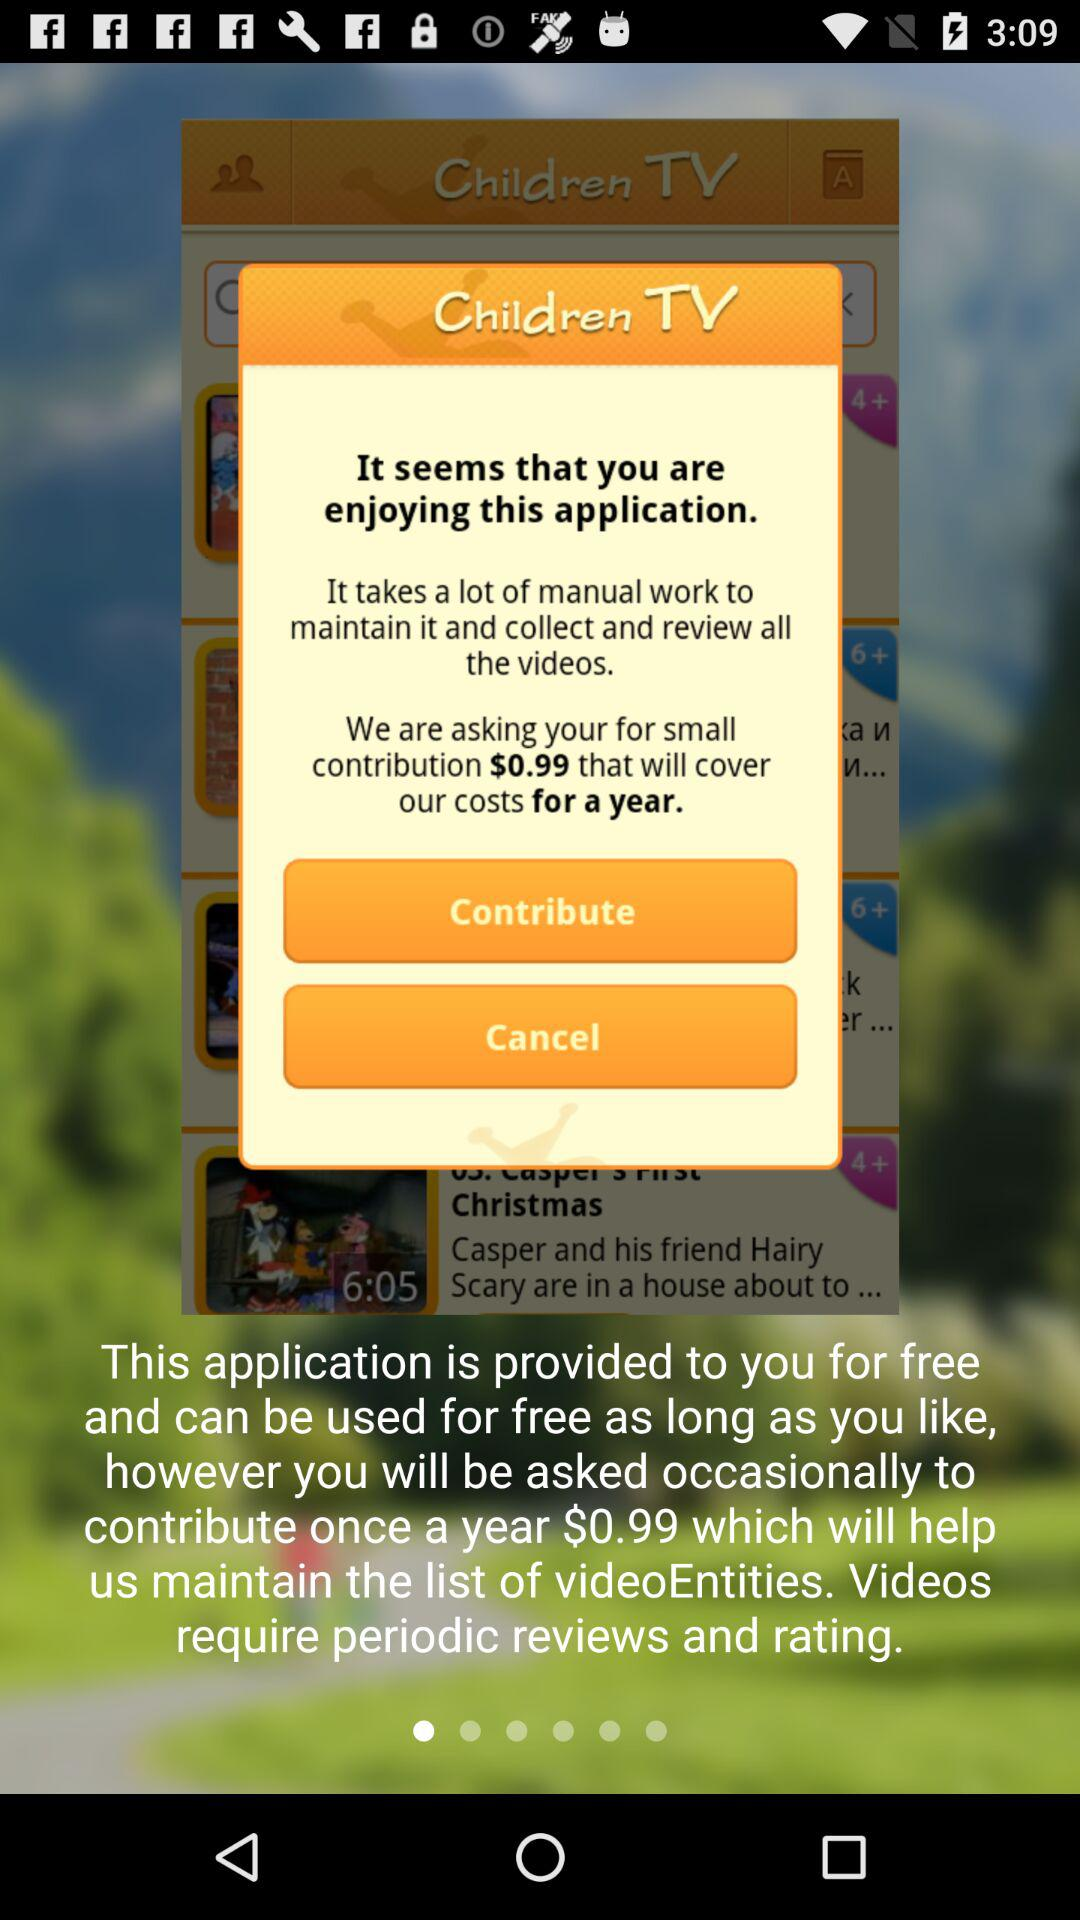What is the cost of one year of maintenance? The cost of one year of maintenance is $0.99. 